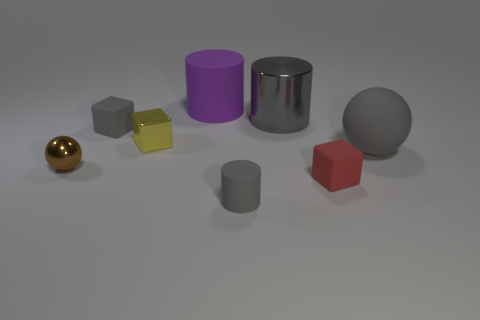Subtract all gray cylinders. How many cylinders are left? 1 Subtract all cyan cylinders. How many purple balls are left? 0 Subtract all yellow cubes. How many cubes are left? 2 Subtract 0 cyan blocks. How many objects are left? 8 Subtract all blocks. How many objects are left? 5 Subtract 2 balls. How many balls are left? 0 Subtract all brown balls. Subtract all yellow blocks. How many balls are left? 1 Subtract all small yellow things. Subtract all small brown spheres. How many objects are left? 6 Add 4 rubber objects. How many rubber objects are left? 9 Add 5 large gray rubber spheres. How many large gray rubber spheres exist? 6 